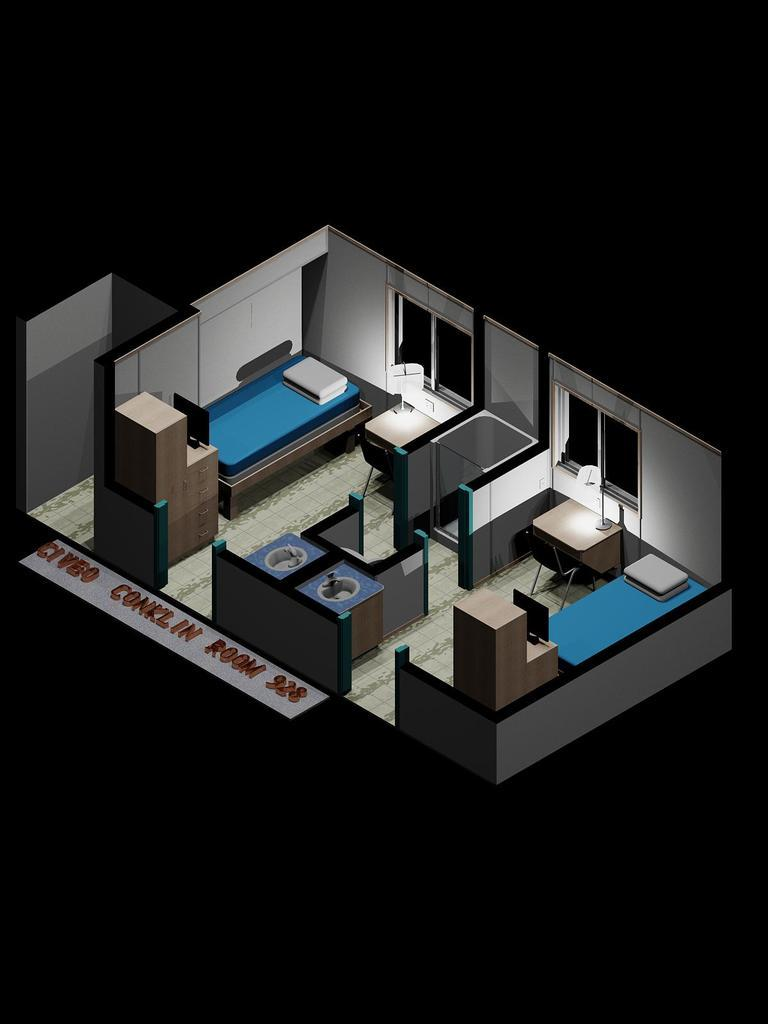How many beds are in the image? There are 2 beds in the image. What other furniture is present in the image? There are 2 tables and 2 lamps in the image. What can be seen through the windows in the image? The information provided does not specify what can be seen through the windows. What type of text or writing is visible in the image? The information provided does not specify the nature of the text or writing. What is the color of the background in the image? The background of the image is dark. Are there any slaves visible in the image? There is no mention of slaves in the image, and therefore no such presence can be confirmed. Can you guide me to the nest in the image? There is no mention of a nest in the image, and therefore no such guidance can be provided. 